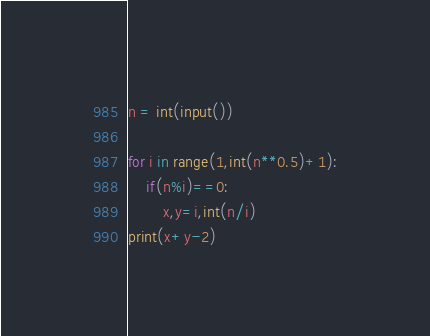<code> <loc_0><loc_0><loc_500><loc_500><_Python_>n = int(input())

for i in range(1,int(n**0.5)+1):
    if(n%i)==0:
        x,y=i,int(n/i)
print(x+y-2)
</code> 